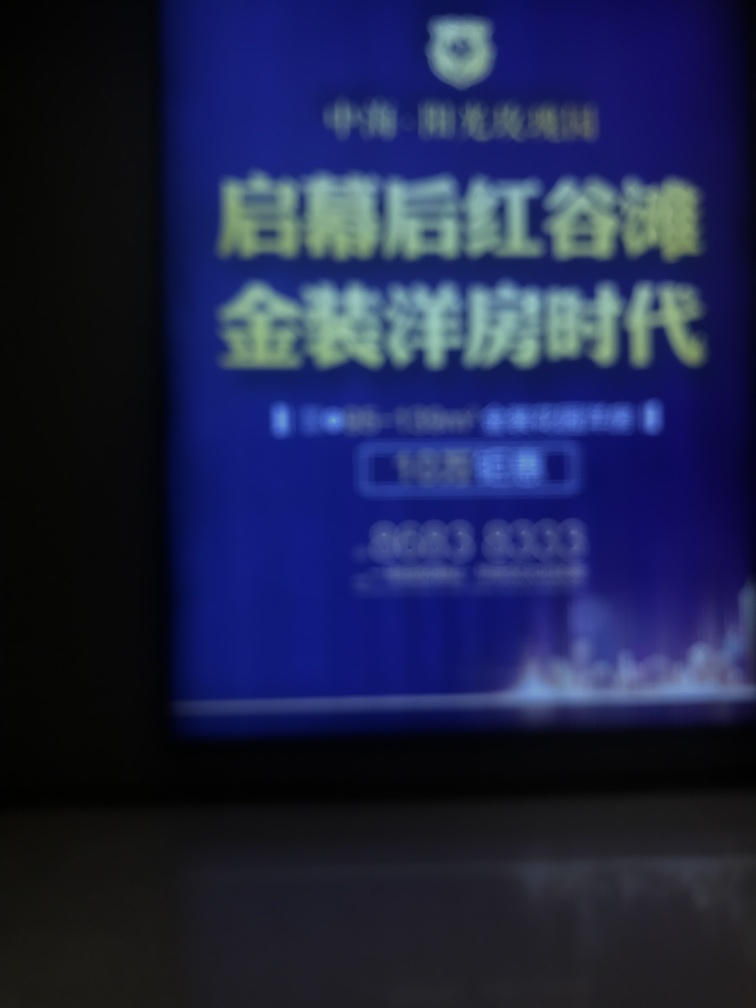Can you provide tips for taking a better photo? Certainly! Ensure the camera lens is clean, use adequate lighting, hold the camera steady or use a tripod, focus on the subject before capturing, and if your device has settings adjustments, use the appropriate ones for your conditions. 